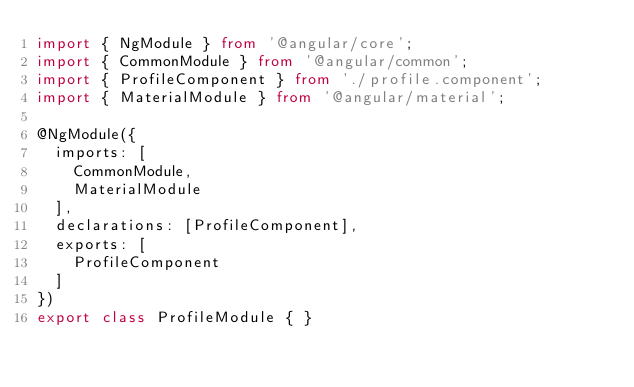Convert code to text. <code><loc_0><loc_0><loc_500><loc_500><_TypeScript_>import { NgModule } from '@angular/core';
import { CommonModule } from '@angular/common';
import { ProfileComponent } from './profile.component';
import { MaterialModule } from '@angular/material';

@NgModule({
  imports: [
    CommonModule,
    MaterialModule
  ],
  declarations: [ProfileComponent],
  exports: [
    ProfileComponent
  ]
})
export class ProfileModule { }
</code> 